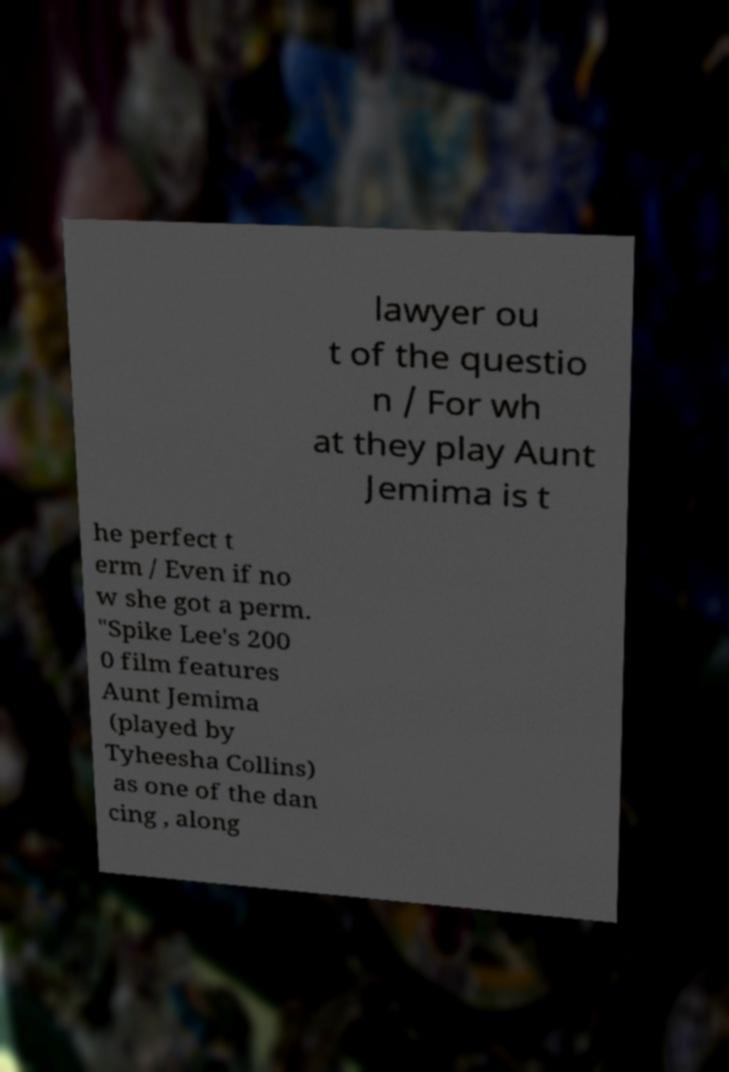I need the written content from this picture converted into text. Can you do that? lawyer ou t of the questio n / For wh at they play Aunt Jemima is t he perfect t erm / Even if no w she got a perm. "Spike Lee's 200 0 film features Aunt Jemima (played by Tyheesha Collins) as one of the dan cing , along 